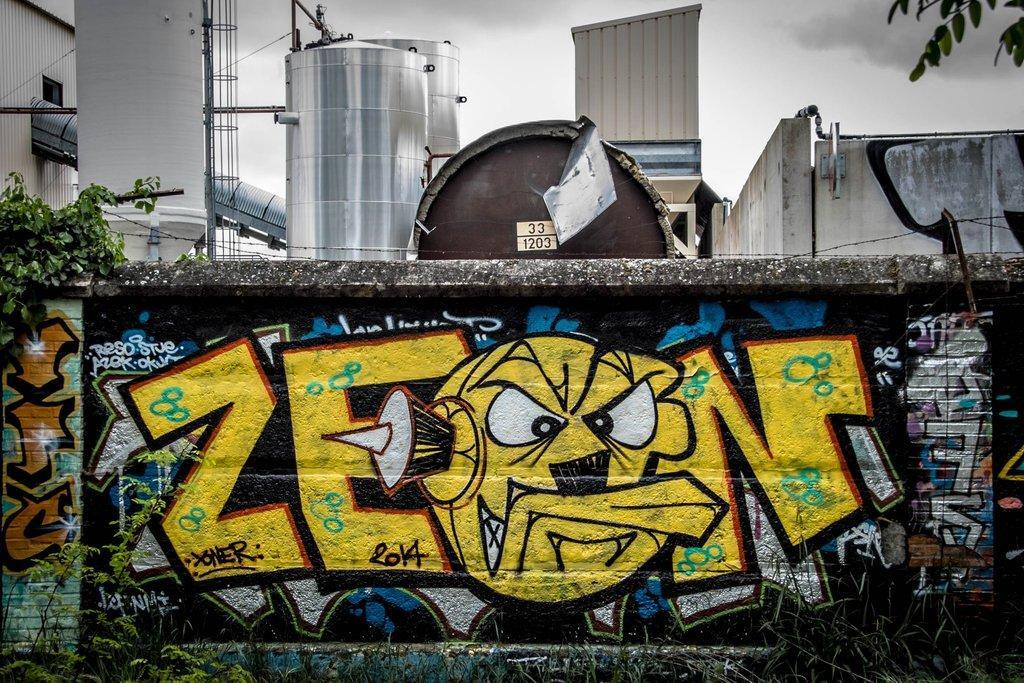How would you summarize this image in a sentence or two? There are paintings on the wall near a plant on the wall. In the background, there are tanks, pillar, tower, wall, building and clouds in the sky. 